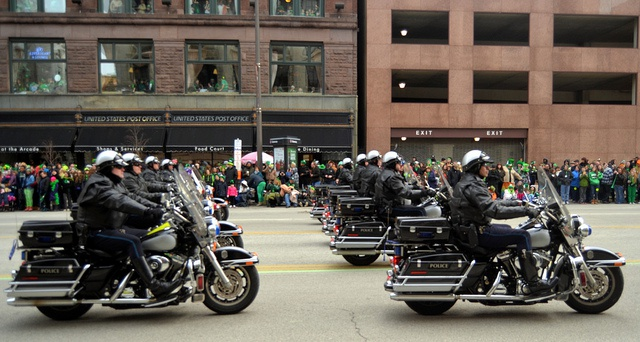Describe the objects in this image and their specific colors. I can see people in brown, black, gray, and darkgray tones, motorcycle in brown, black, gray, and darkgray tones, motorcycle in brown, black, gray, darkgray, and lightgray tones, people in brown, black, gray, darkgray, and white tones, and people in brown, black, gray, darkgray, and white tones in this image. 